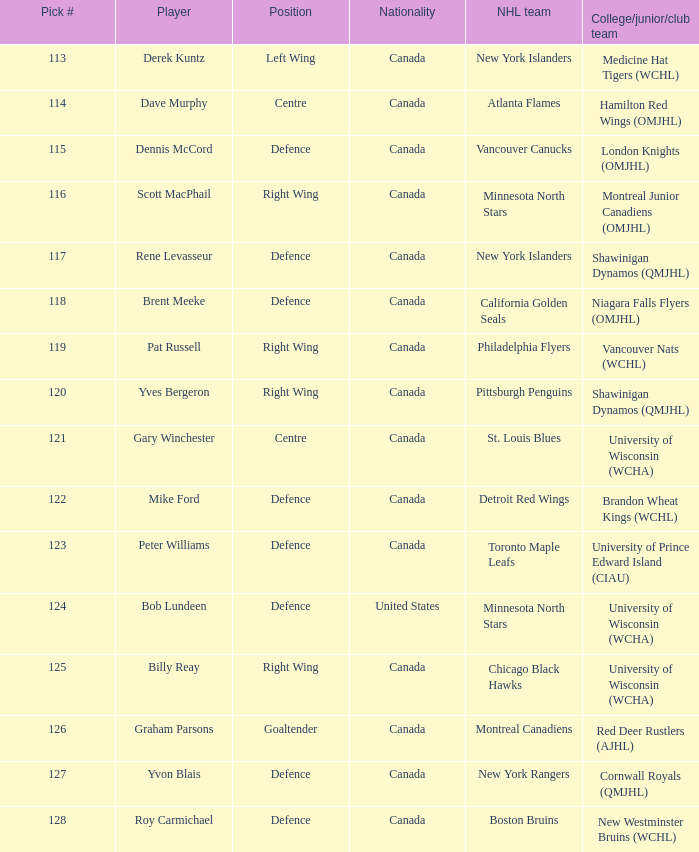Name the position for pick number 128 Defence. 